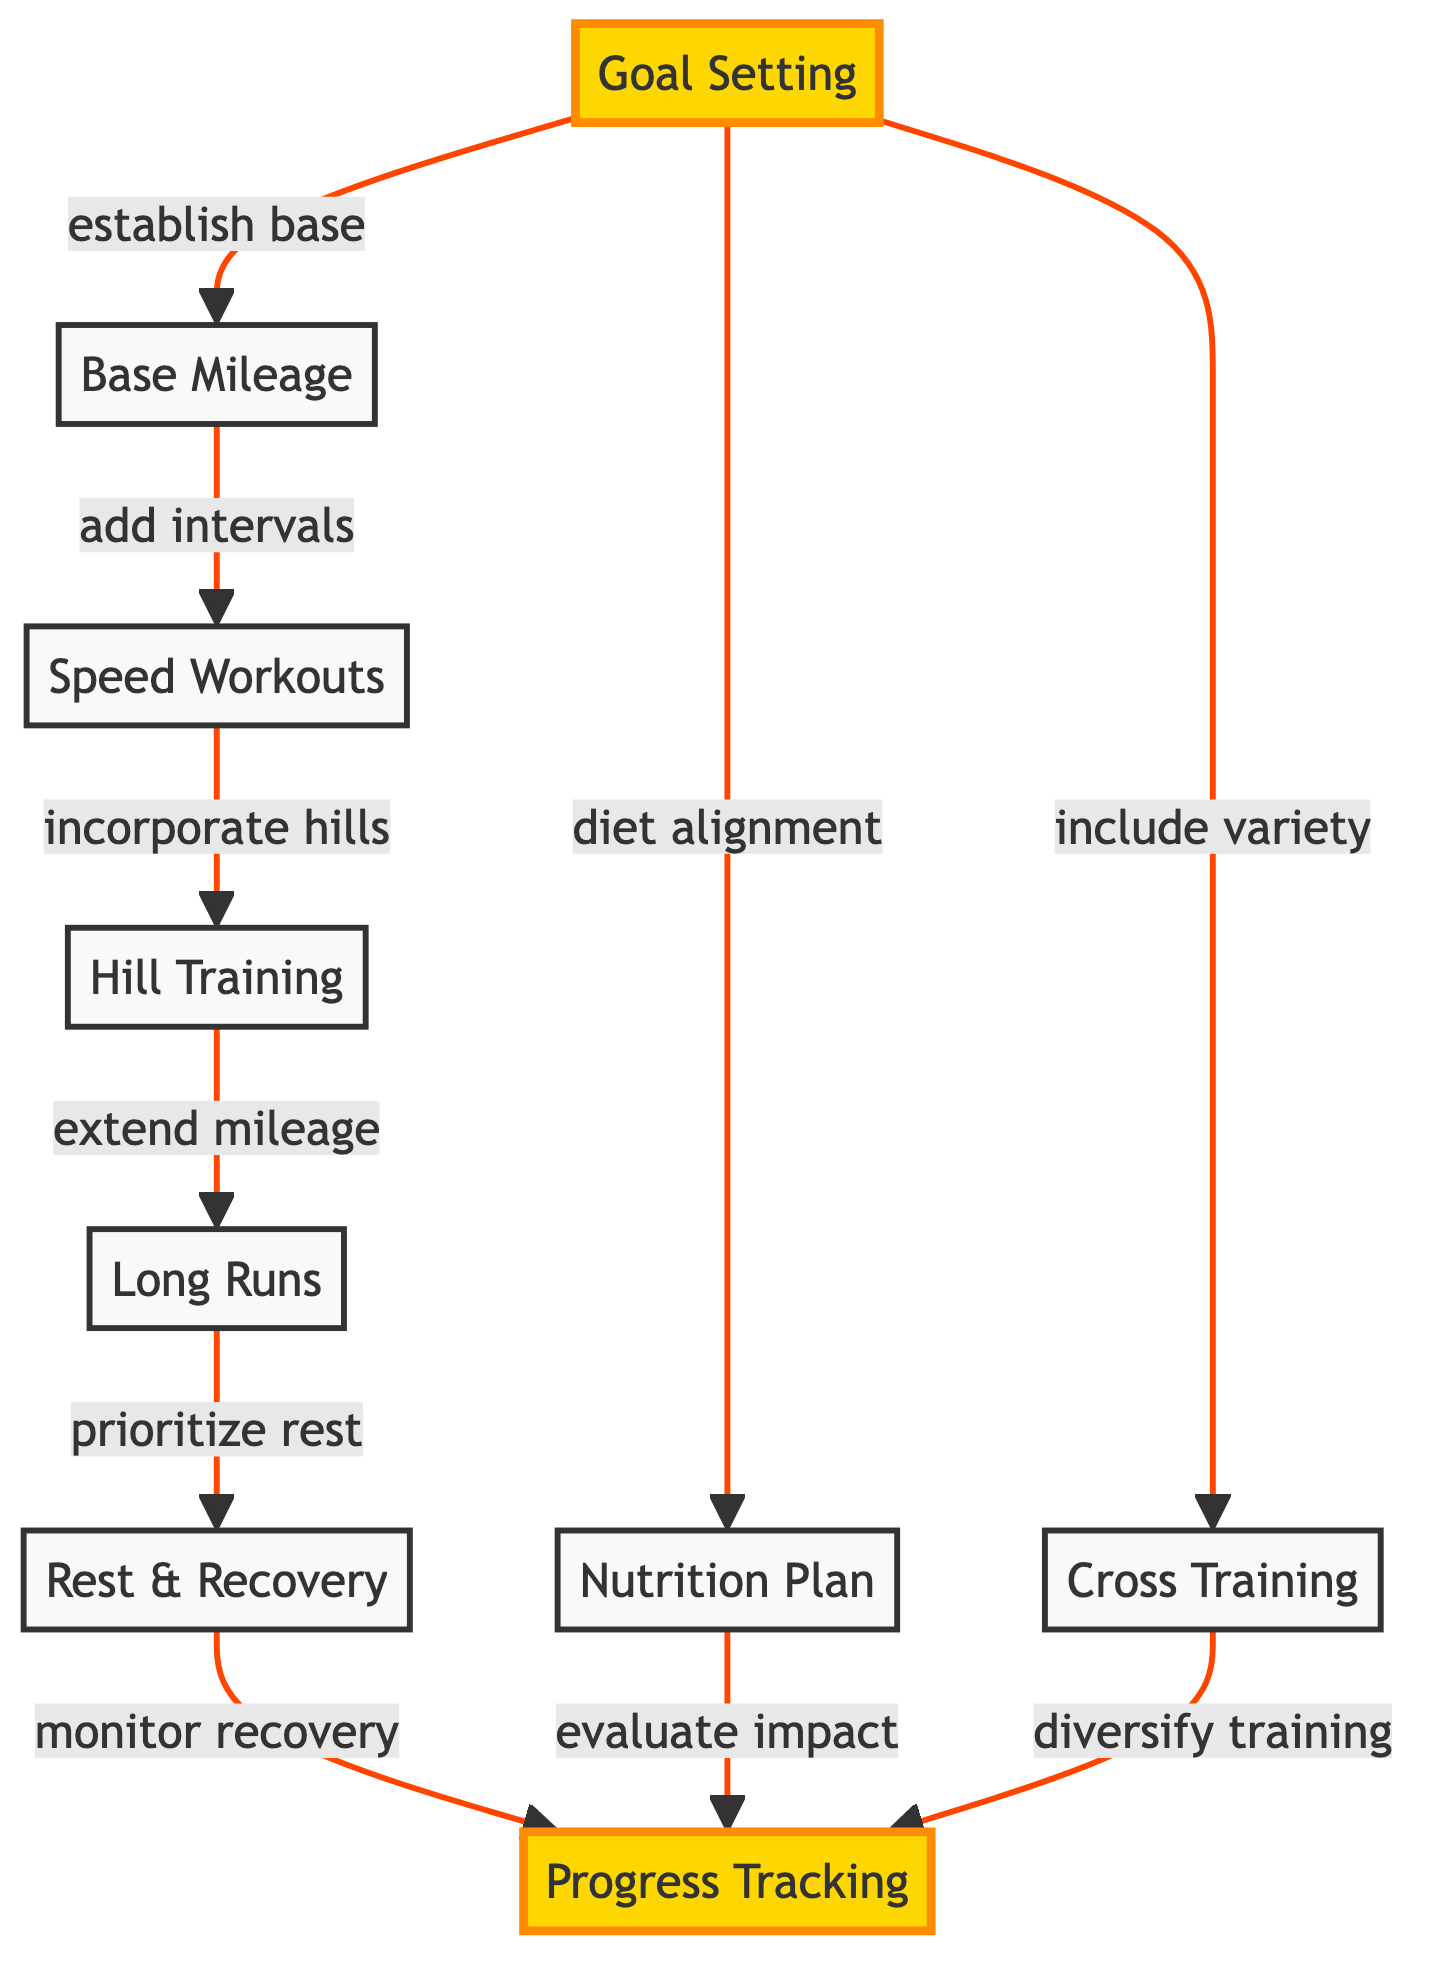What is the starting point of the training routine? The diagram indicates that the starting point is "Goal Setting." This node connects to several other nodes that represent subsequent steps in the training routine.
Answer: Goal Setting How many nodes are present in the diagram? By counting the unique nodes representing different aspects of the training process, we find there are 9 nodes total.
Answer: 9 Which node comes after "Base Mileage"? Following the directed edge from "Base Mileage," the next node is "Speed Workouts," indicating a sequential step in the training progression.
Answer: Speed Workouts What is the relationship between "Rest & Recovery" and "Progress Tracking"? "Rest & Recovery" is directly connected to "Progress Tracking" with the label "monitor recovery," indicating that evaluating recovery is part of tracking progress during training.
Answer: monitor recovery What two nodes are linked to "Goal Setting"? The "Goal Setting" node has two outgoing connections: one to "Nutrition Plan" (labeled as "diet alignment") and the other to "Cross Training" (labeled as "include variety").
Answer: Nutrition Plan, Cross Training Which node follows "Hill Training" in the sequence? The sequence from "Hill Training" leads to "Long Runs," marking the next stage of increasing mileage within the training routine.
Answer: Long Runs How does "Cross Training" impact "Progress Tracking"? "Cross Training" connects to "Progress Tracking" with the label "diversify training," indicating that participation in cross training helps in evaluating progress.
Answer: diversify training What is the final step before tracking progress? The last step prior to "Progress Tracking" is "Rest & Recovery," which emphasizes the importance of prioritizing recovery after training efforts before assessing progress.
Answer: Rest & Recovery Which node evaluates the impact of nutrition on training? The node "Nutrition Plan" has a direct connection to "Progress Tracking" with the label "evaluate impact," showing its role in assessing how nutrition affects overall training outcomes.
Answer: evaluate impact 